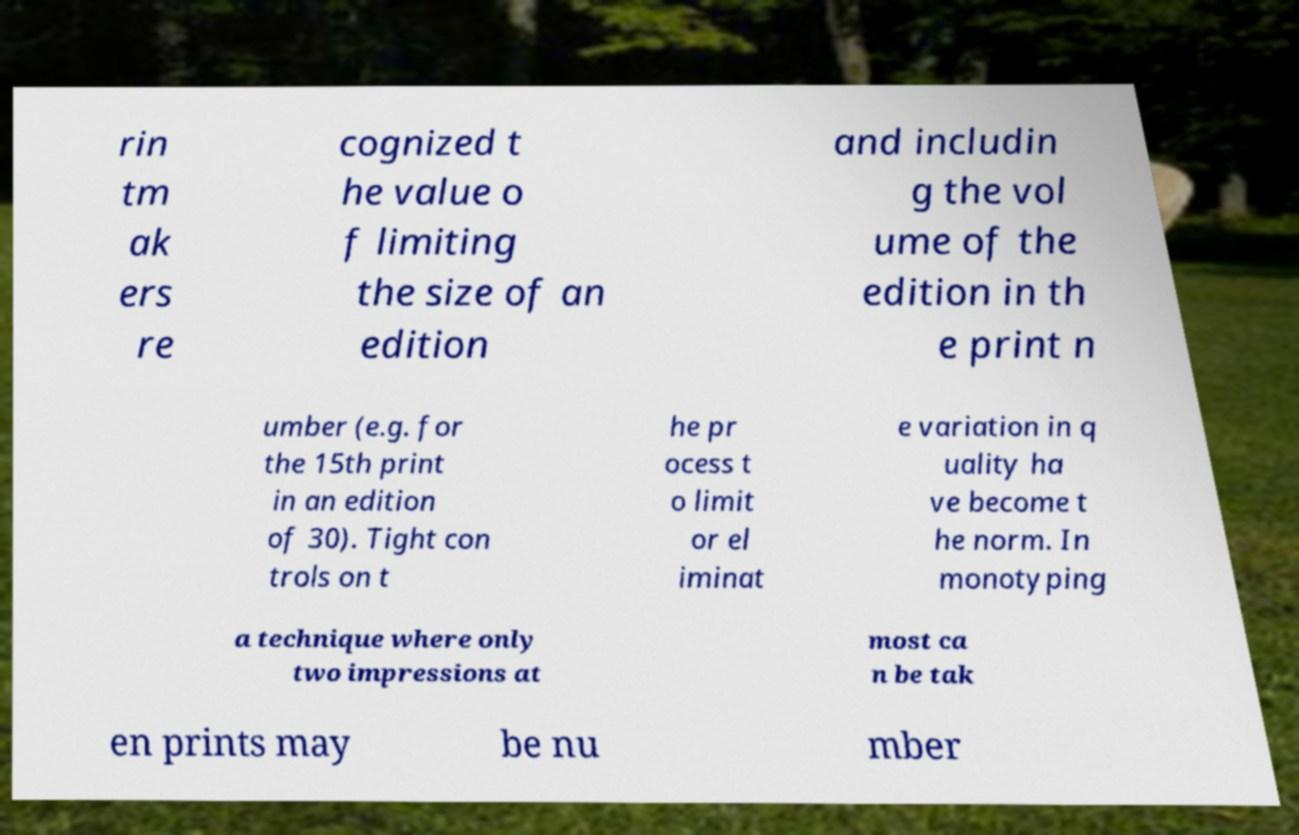I need the written content from this picture converted into text. Can you do that? rin tm ak ers re cognized t he value o f limiting the size of an edition and includin g the vol ume of the edition in th e print n umber (e.g. for the 15th print in an edition of 30). Tight con trols on t he pr ocess t o limit or el iminat e variation in q uality ha ve become t he norm. In monotyping a technique where only two impressions at most ca n be tak en prints may be nu mber 